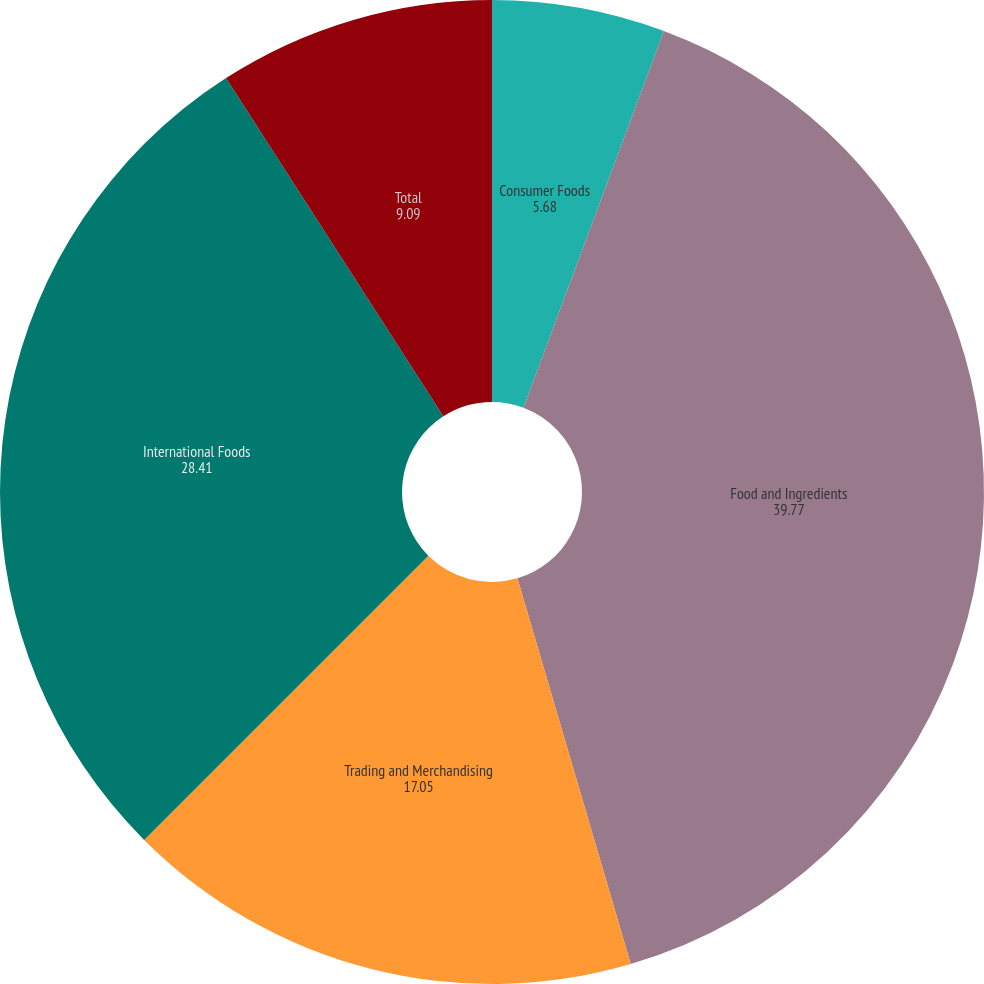<chart> <loc_0><loc_0><loc_500><loc_500><pie_chart><fcel>Consumer Foods<fcel>Food and Ingredients<fcel>Trading and Merchandising<fcel>International Foods<fcel>Total<nl><fcel>5.68%<fcel>39.77%<fcel>17.05%<fcel>28.41%<fcel>9.09%<nl></chart> 